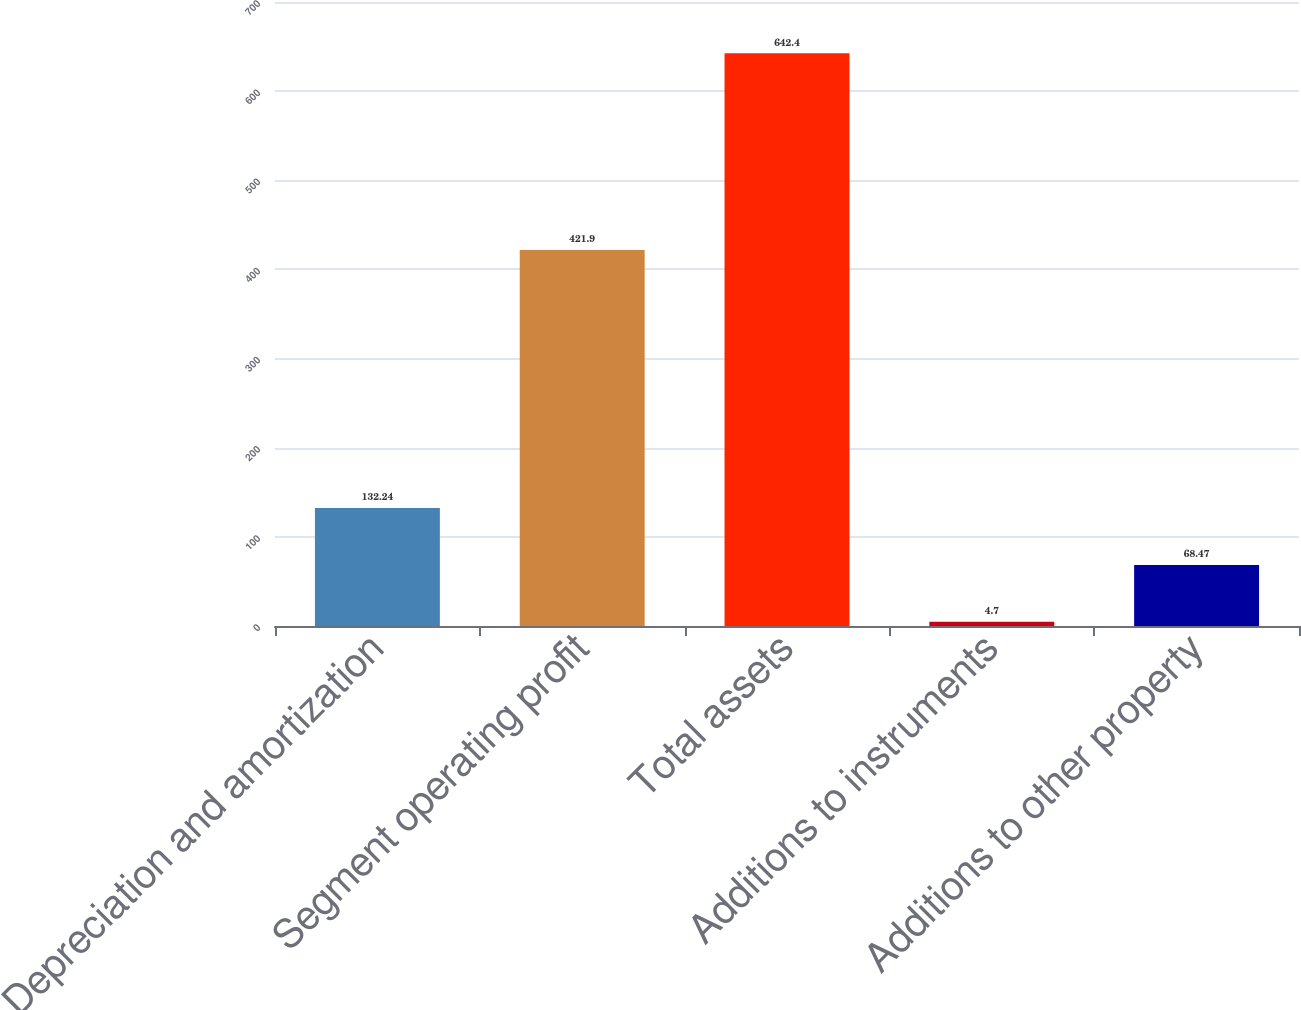Convert chart to OTSL. <chart><loc_0><loc_0><loc_500><loc_500><bar_chart><fcel>Depreciation and amortization<fcel>Segment operating profit<fcel>Total assets<fcel>Additions to instruments<fcel>Additions to other property<nl><fcel>132.24<fcel>421.9<fcel>642.4<fcel>4.7<fcel>68.47<nl></chart> 